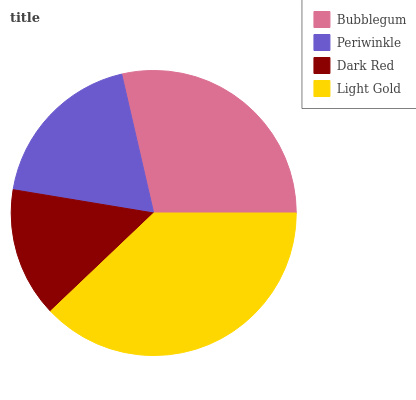Is Dark Red the minimum?
Answer yes or no. Yes. Is Light Gold the maximum?
Answer yes or no. Yes. Is Periwinkle the minimum?
Answer yes or no. No. Is Periwinkle the maximum?
Answer yes or no. No. Is Bubblegum greater than Periwinkle?
Answer yes or no. Yes. Is Periwinkle less than Bubblegum?
Answer yes or no. Yes. Is Periwinkle greater than Bubblegum?
Answer yes or no. No. Is Bubblegum less than Periwinkle?
Answer yes or no. No. Is Bubblegum the high median?
Answer yes or no. Yes. Is Periwinkle the low median?
Answer yes or no. Yes. Is Light Gold the high median?
Answer yes or no. No. Is Bubblegum the low median?
Answer yes or no. No. 